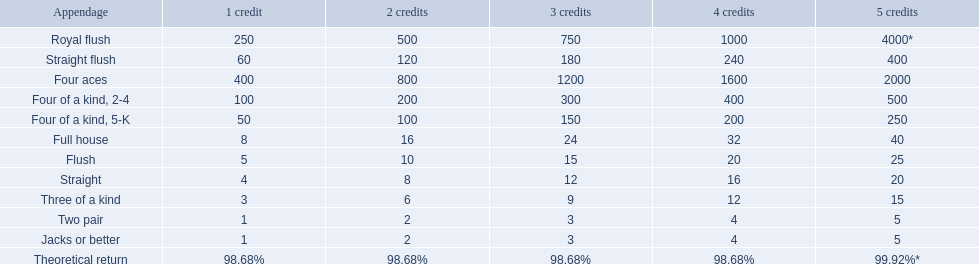What are the hands? Royal flush, Straight flush, Four aces, Four of a kind, 2-4, Four of a kind, 5-K, Full house, Flush, Straight, Three of a kind, Two pair, Jacks or better. Would you mind parsing the complete table? {'header': ['Appendage', '1 credit', '2 credits', '3 credits', '4 credits', '5 credits'], 'rows': [['Royal flush', '250', '500', '750', '1000', '4000*'], ['Straight flush', '60', '120', '180', '240', '400'], ['Four aces', '400', '800', '1200', '1600', '2000'], ['Four of a kind, 2-4', '100', '200', '300', '400', '500'], ['Four of a kind, 5-K', '50', '100', '150', '200', '250'], ['Full house', '8', '16', '24', '32', '40'], ['Flush', '5', '10', '15', '20', '25'], ['Straight', '4', '8', '12', '16', '20'], ['Three of a kind', '3', '6', '9', '12', '15'], ['Two pair', '1', '2', '3', '4', '5'], ['Jacks or better', '1', '2', '3', '4', '5'], ['Theoretical return', '98.68%', '98.68%', '98.68%', '98.68%', '99.92%*']]} Which hand is on the top? Royal flush. 